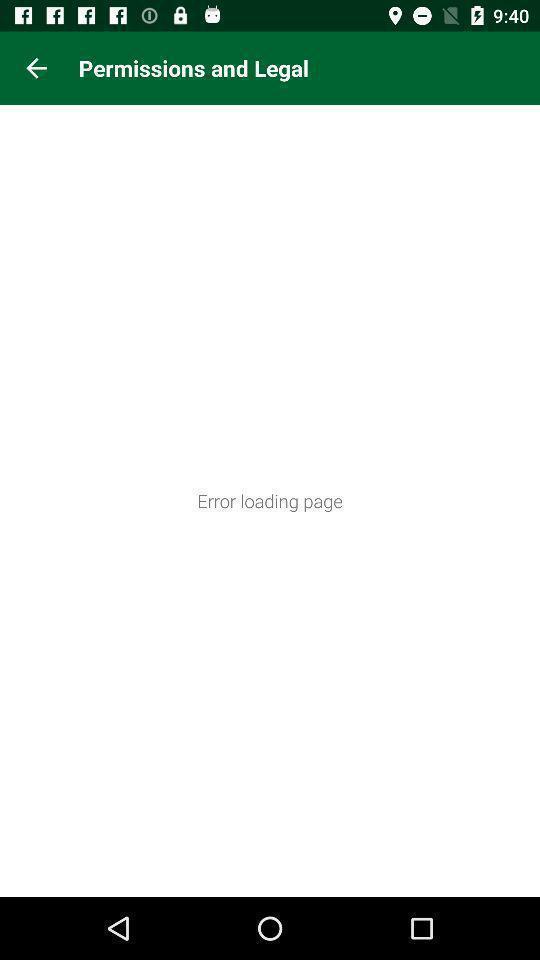Tell me about the visual elements in this screen capture. Page showing an error loading page. 